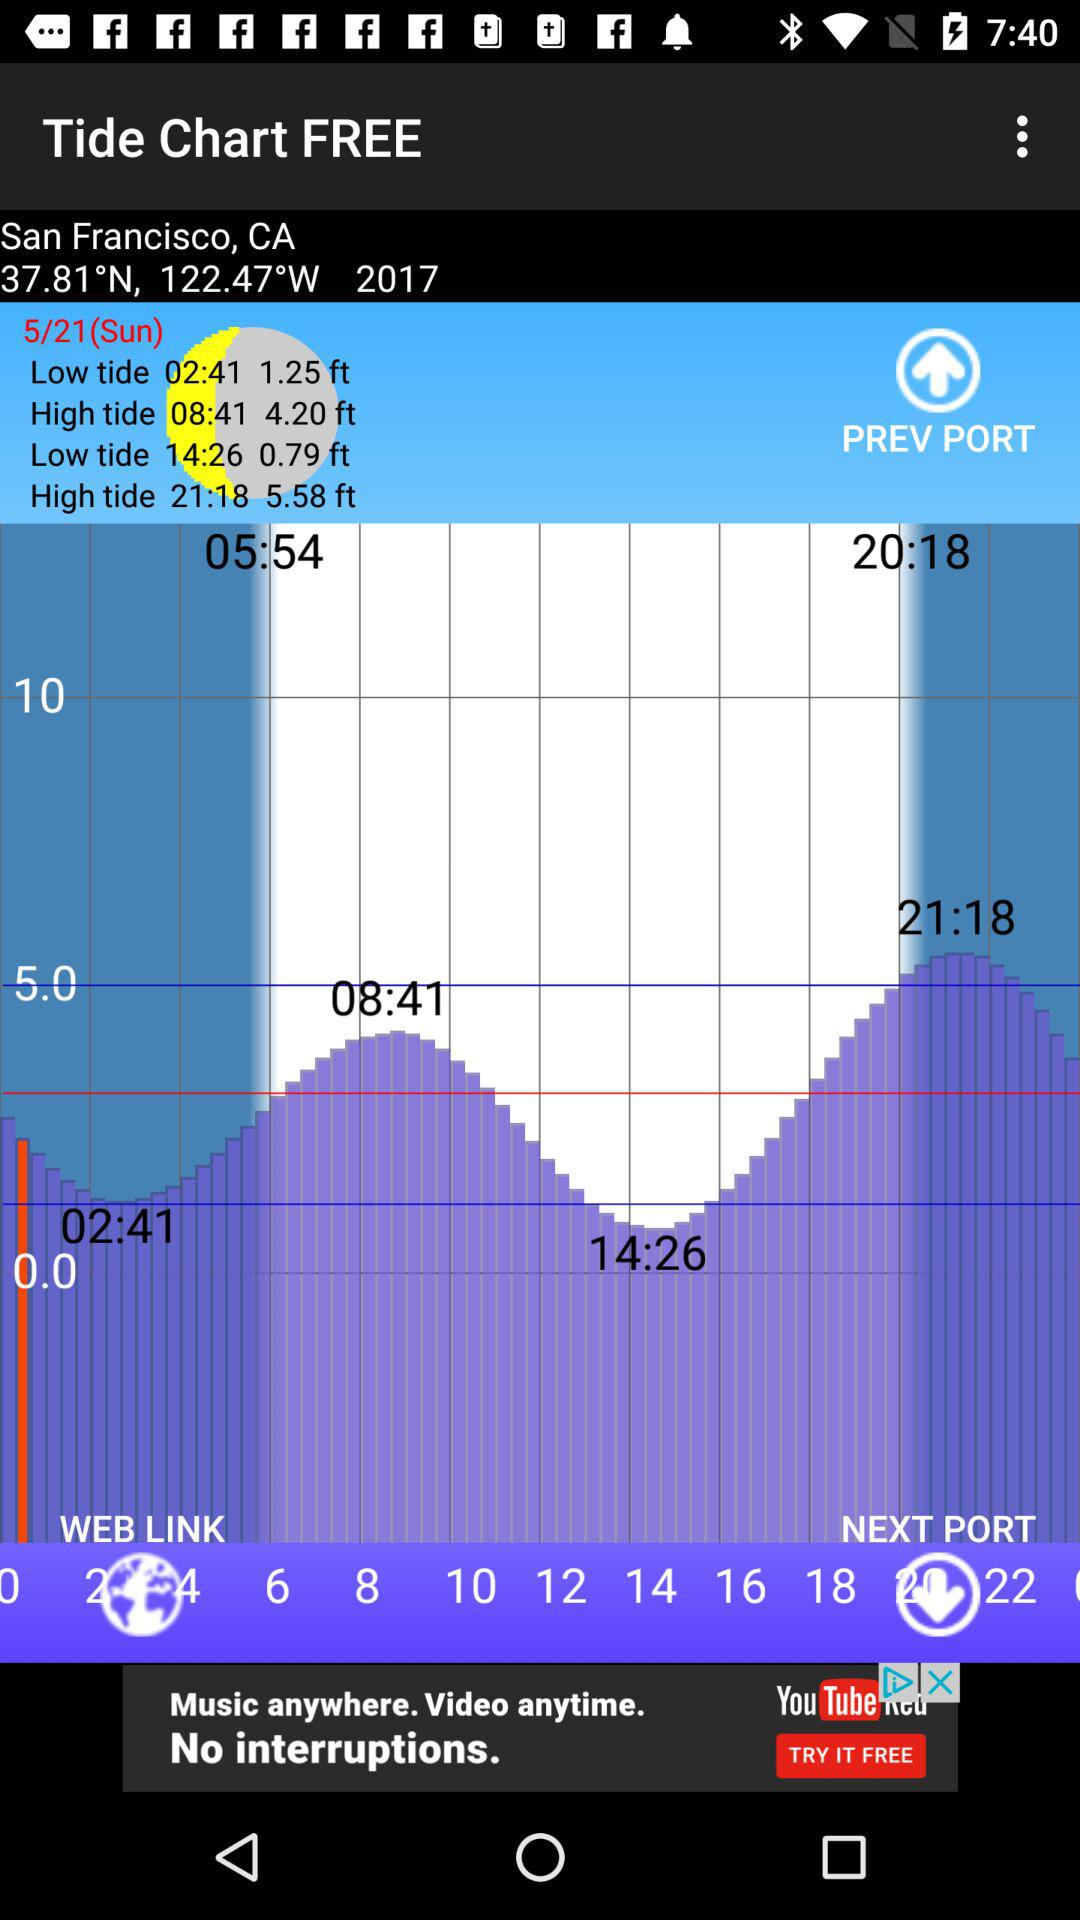How many hours apart are the high tides?
Answer the question using a single word or phrase. 13 hours 